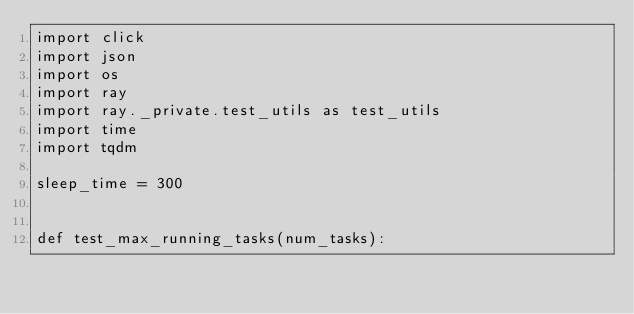<code> <loc_0><loc_0><loc_500><loc_500><_Python_>import click
import json
import os
import ray
import ray._private.test_utils as test_utils
import time
import tqdm

sleep_time = 300


def test_max_running_tasks(num_tasks):</code> 